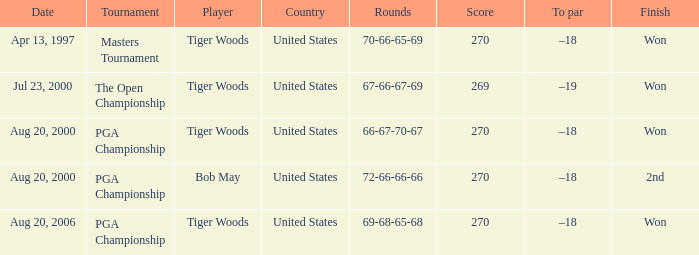What is the most dreadful (highest) score? 270.0. Help me parse the entirety of this table. {'header': ['Date', 'Tournament', 'Player', 'Country', 'Rounds', 'Score', 'To par', 'Finish'], 'rows': [['Apr 13, 1997', 'Masters Tournament', 'Tiger Woods', 'United States', '70-66-65-69', '270', '–18', 'Won'], ['Jul 23, 2000', 'The Open Championship', 'Tiger Woods', 'United States', '67-66-67-69', '269', '–19', 'Won'], ['Aug 20, 2000', 'PGA Championship', 'Tiger Woods', 'United States', '66-67-70-67', '270', '–18', 'Won'], ['Aug 20, 2000', 'PGA Championship', 'Bob May', 'United States', '72-66-66-66', '270', '–18', '2nd'], ['Aug 20, 2006', 'PGA Championship', 'Tiger Woods', 'United States', '69-68-65-68', '270', '–18', 'Won']]} 